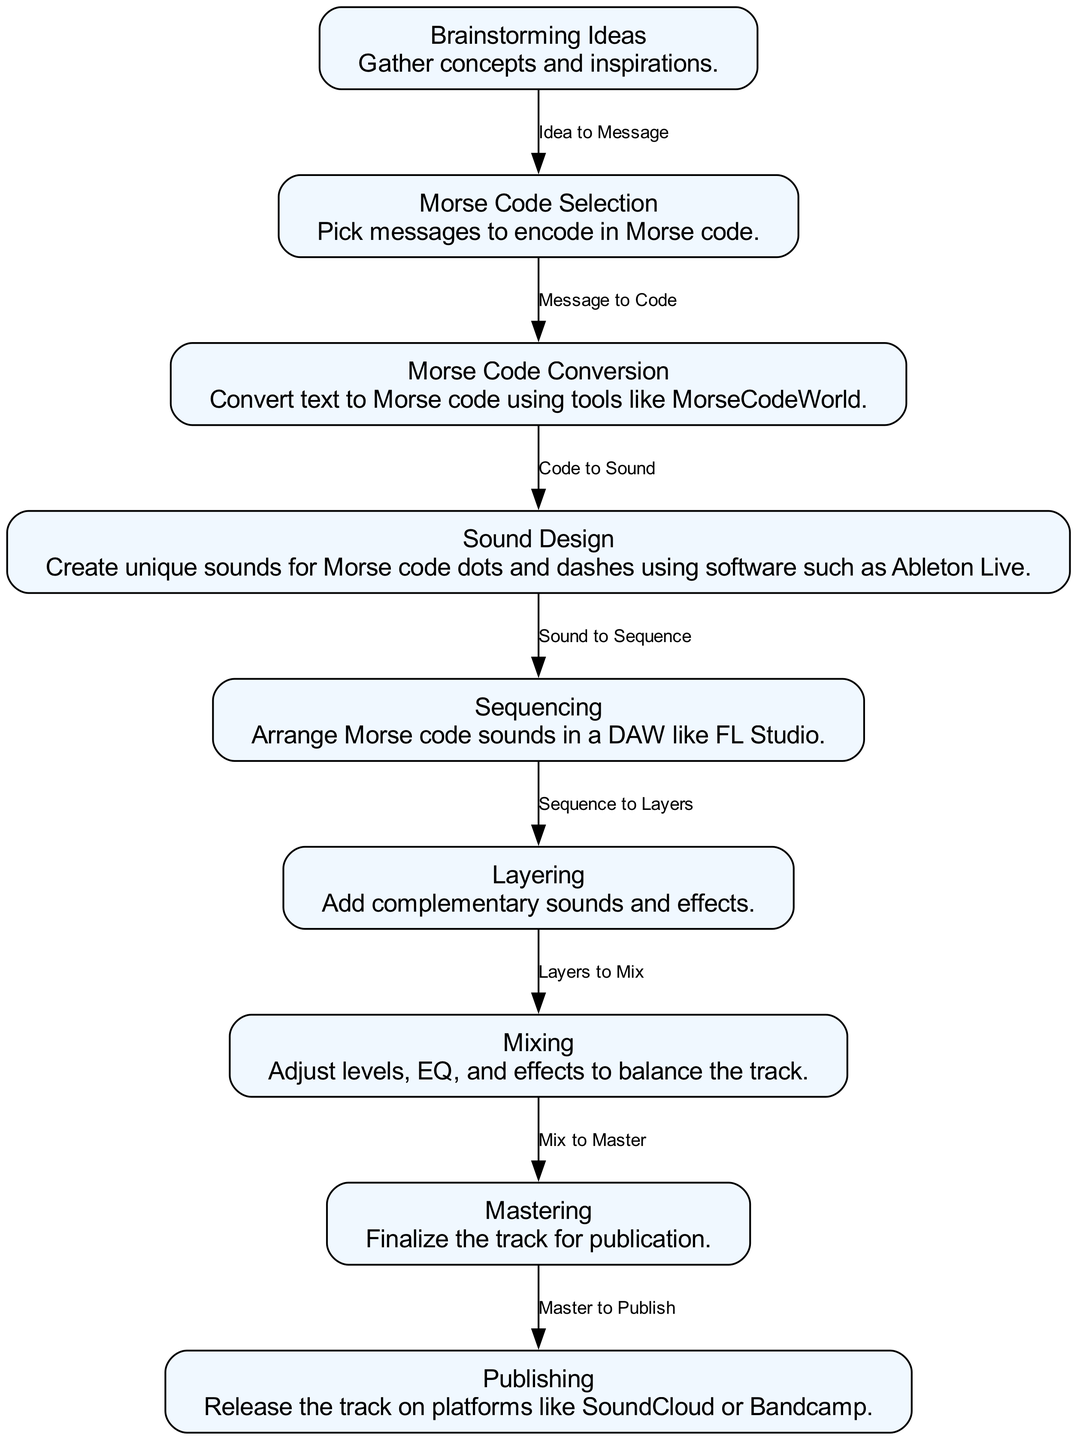What is the first step in the workflow? The first step in the workflow is labeled "Brainstorming Ideas," which involves gathering concepts and inspirations.
Answer: Brainstorming Ideas How many total nodes are in the diagram? Counting the nodes listed in the data, there are nine nodes representing different steps in the workflow.
Answer: 9 Which step follows "Morse Code Selection"? The step that follows "Morse Code Selection" is "Morse Code Conversion," where the selected messages are converted into Morse code.
Answer: Morse Code Conversion What is the final step before publishing? The final step before publishing is "Mastering," which involves finalizing the track for publication.
Answer: Mastering What is the relationship between "Layering" and "Mixing"? The relationship is that "Layering" precedes "Mixing," meaning layers of sound are created before adjusting levels and effects in the mixing process.
Answer: Layers to Mix What tool is suggested for sound design in this workflow? The diagram suggests using "Ableton Live" for sound design, specifically for creating unique sounds for Morse code.
Answer: Ableton Live What do we do in the "Sequencing" step? In the "Sequencing" step, you arrange Morse code sounds within a Digital Audio Workstation (DAW), such as FL Studio.
Answer: Arrange Morse code sounds Which node represents the transition from mixing to mastering? The transition from mixing to mastering is represented by the edge labeled "Mix to Master," connecting the "Mixing" node to the "Mastering" node.
Answer: Mix to Master What is the last action in the workflow? The last action in the workflow is "Publishing," which involves releasing the track on various music platforms.
Answer: Publishing 